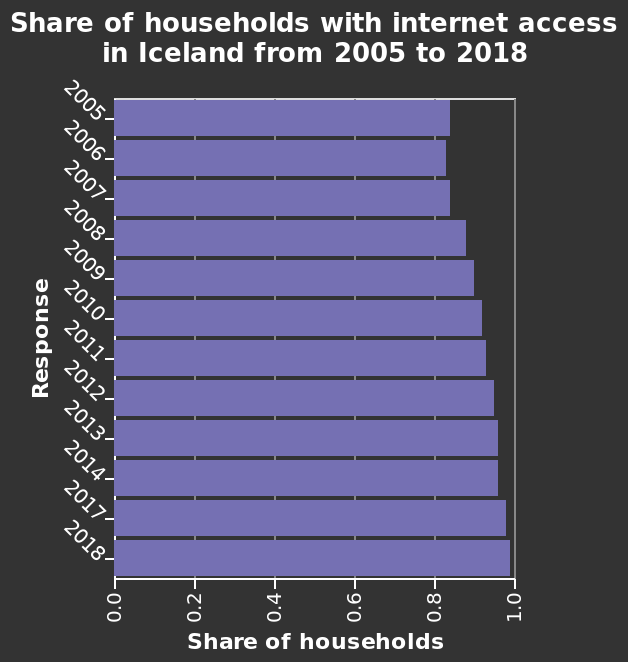<image>
What is the time period covered by the bar plot? The bar plot represents the time period from 2005 to 2018. Offer a thorough analysis of the image. Share of households with internet access in Iceland from 2005 to 2018 was steadily increasing. There was no increase between 2013-2014. The highest number was noticed in 2018 while the lowest in 2005. The most rapid increase was noticed in 2008. The number of share was never below 0.8. What is the trend of internet popularity in Iceland? The internet is becoming more popular in Iceland with each passing year and its usage is growing. Describe the following image in detail Here a is a bar plot titled Share of households with internet access in Iceland from 2005 to 2018. A linear scale of range 0.0 to 1.0 can be found on the x-axis, labeled Share of households. The y-axis shows Response. Is the internet gaining more popularity in Iceland? Yes, the internet is gaining more popularity in Iceland as the years go by. How popular is the internet in Iceland?  The internet is becoming increasingly popular year on year in Iceland and is growing. Is internet usage increasing in Iceland?  Yes, internet usage is growing in Iceland year on year. How is internet usage changing over the years in Iceland? Internet usage is increasing year on year in Iceland, making it more popular than ever. Is the internet becoming less popular in Iceland with each passing year and its usage declining? No.The internet is becoming more popular in Iceland with each passing year and its usage is growing. 